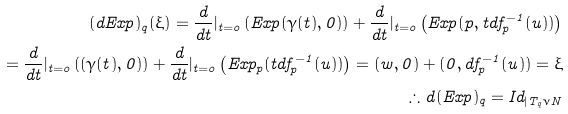<formula> <loc_0><loc_0><loc_500><loc_500>( d E x p ) _ { q } ( \xi ) = \frac { d } { d t } { | _ { t = o } } \left ( E x p ( \gamma ( t ) , 0 ) \right ) + \frac { d } { d t } { | _ { t = o } } \left ( E x p ( p , t d f _ { p } ^ { - 1 } ( u ) ) \right ) \\ = \frac { d } { d t } { | _ { t = o } } \left ( ( \gamma ( t ) , 0 ) \right ) + \frac { d } { d t } { | _ { t = o } } \left ( E x p _ { p } ( t d f _ { p } ^ { - 1 } ( u ) ) \right ) = ( w , 0 ) + ( 0 , d f _ { p } ^ { - 1 } ( u ) ) = \xi \\ \therefore d ( E x p ) _ { q } = I d _ { | T _ { q } \nu { N } }</formula> 